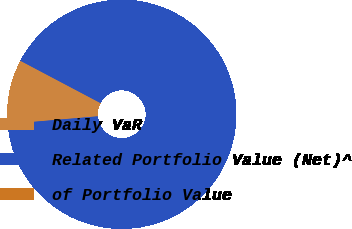<chart> <loc_0><loc_0><loc_500><loc_500><pie_chart><fcel>Daily VaR<fcel>Related Portfolio Value (Net)^<fcel>of Portfolio Value<nl><fcel>9.09%<fcel>90.91%<fcel>0.0%<nl></chart> 